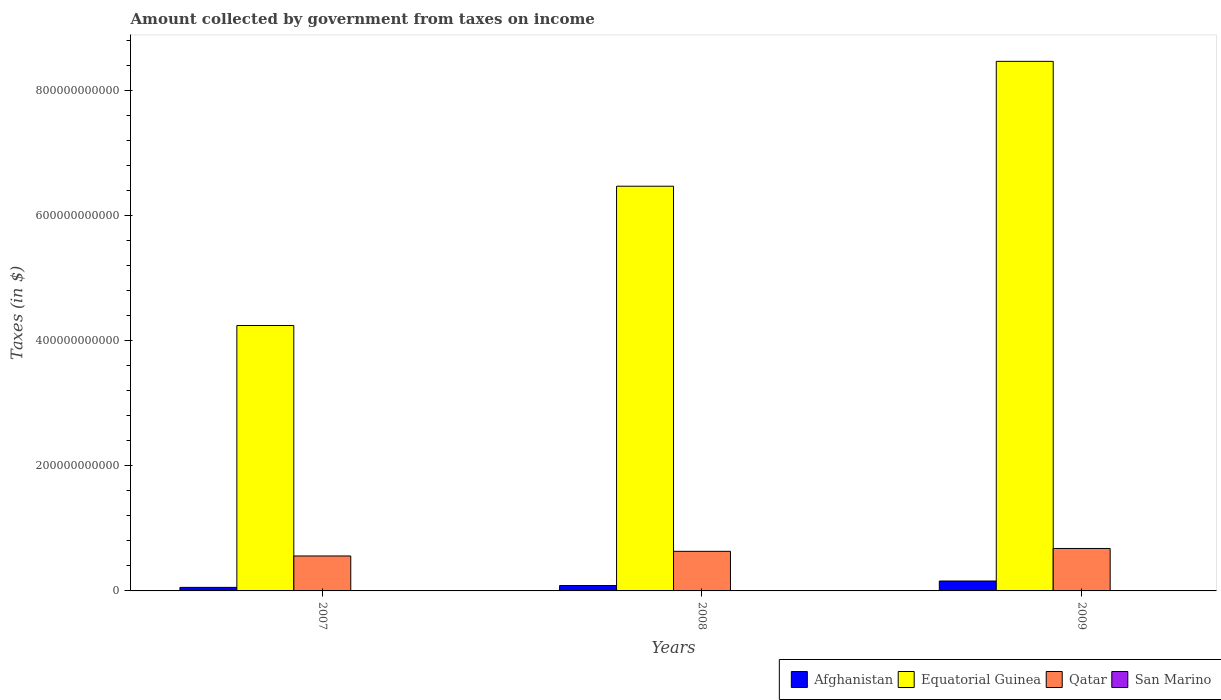How many different coloured bars are there?
Offer a terse response. 4. How many groups of bars are there?
Your answer should be compact. 3. Are the number of bars on each tick of the X-axis equal?
Your answer should be compact. Yes. In how many cases, is the number of bars for a given year not equal to the number of legend labels?
Give a very brief answer. 0. What is the amount collected by government from taxes on income in Equatorial Guinea in 2007?
Provide a succinct answer. 4.24e+11. Across all years, what is the maximum amount collected by government from taxes on income in Qatar?
Your response must be concise. 6.78e+1. Across all years, what is the minimum amount collected by government from taxes on income in San Marino?
Give a very brief answer. 9.80e+07. What is the total amount collected by government from taxes on income in San Marino in the graph?
Offer a terse response. 3.13e+08. What is the difference between the amount collected by government from taxes on income in San Marino in 2007 and that in 2009?
Your answer should be compact. 7.55e+06. What is the difference between the amount collected by government from taxes on income in Afghanistan in 2007 and the amount collected by government from taxes on income in Equatorial Guinea in 2009?
Offer a very short reply. -8.41e+11. What is the average amount collected by government from taxes on income in Equatorial Guinea per year?
Your response must be concise. 6.39e+11. In the year 2008, what is the difference between the amount collected by government from taxes on income in Qatar and amount collected by government from taxes on income in Afghanistan?
Provide a succinct answer. 5.47e+1. What is the ratio of the amount collected by government from taxes on income in Equatorial Guinea in 2007 to that in 2008?
Ensure brevity in your answer.  0.66. What is the difference between the highest and the second highest amount collected by government from taxes on income in Afghanistan?
Make the answer very short. 7.23e+09. What is the difference between the highest and the lowest amount collected by government from taxes on income in Afghanistan?
Your response must be concise. 1.02e+1. In how many years, is the amount collected by government from taxes on income in Equatorial Guinea greater than the average amount collected by government from taxes on income in Equatorial Guinea taken over all years?
Provide a short and direct response. 2. Is it the case that in every year, the sum of the amount collected by government from taxes on income in Qatar and amount collected by government from taxes on income in San Marino is greater than the sum of amount collected by government from taxes on income in Afghanistan and amount collected by government from taxes on income in Equatorial Guinea?
Your answer should be compact. Yes. What does the 3rd bar from the left in 2009 represents?
Keep it short and to the point. Qatar. What does the 4th bar from the right in 2007 represents?
Your answer should be very brief. Afghanistan. Are all the bars in the graph horizontal?
Make the answer very short. No. What is the difference between two consecutive major ticks on the Y-axis?
Ensure brevity in your answer.  2.00e+11. Does the graph contain any zero values?
Your answer should be compact. No. Does the graph contain grids?
Provide a short and direct response. No. Where does the legend appear in the graph?
Provide a short and direct response. Bottom right. How many legend labels are there?
Give a very brief answer. 4. How are the legend labels stacked?
Provide a short and direct response. Horizontal. What is the title of the graph?
Your answer should be very brief. Amount collected by government from taxes on income. Does "Moldova" appear as one of the legend labels in the graph?
Make the answer very short. No. What is the label or title of the X-axis?
Ensure brevity in your answer.  Years. What is the label or title of the Y-axis?
Ensure brevity in your answer.  Taxes (in $). What is the Taxes (in $) of Afghanistan in 2007?
Make the answer very short. 5.64e+09. What is the Taxes (in $) of Equatorial Guinea in 2007?
Provide a short and direct response. 4.24e+11. What is the Taxes (in $) of Qatar in 2007?
Make the answer very short. 5.58e+1. What is the Taxes (in $) of San Marino in 2007?
Make the answer very short. 1.06e+08. What is the Taxes (in $) in Afghanistan in 2008?
Offer a terse response. 8.62e+09. What is the Taxes (in $) of Equatorial Guinea in 2008?
Provide a succinct answer. 6.47e+11. What is the Taxes (in $) of Qatar in 2008?
Give a very brief answer. 6.33e+1. What is the Taxes (in $) in San Marino in 2008?
Ensure brevity in your answer.  1.09e+08. What is the Taxes (in $) of Afghanistan in 2009?
Give a very brief answer. 1.58e+1. What is the Taxes (in $) in Equatorial Guinea in 2009?
Your response must be concise. 8.46e+11. What is the Taxes (in $) in Qatar in 2009?
Offer a very short reply. 6.78e+1. What is the Taxes (in $) in San Marino in 2009?
Ensure brevity in your answer.  9.80e+07. Across all years, what is the maximum Taxes (in $) of Afghanistan?
Provide a short and direct response. 1.58e+1. Across all years, what is the maximum Taxes (in $) in Equatorial Guinea?
Give a very brief answer. 8.46e+11. Across all years, what is the maximum Taxes (in $) of Qatar?
Provide a short and direct response. 6.78e+1. Across all years, what is the maximum Taxes (in $) of San Marino?
Your answer should be compact. 1.09e+08. Across all years, what is the minimum Taxes (in $) of Afghanistan?
Provide a succinct answer. 5.64e+09. Across all years, what is the minimum Taxes (in $) in Equatorial Guinea?
Provide a short and direct response. 4.24e+11. Across all years, what is the minimum Taxes (in $) in Qatar?
Provide a short and direct response. 5.58e+1. Across all years, what is the minimum Taxes (in $) in San Marino?
Keep it short and to the point. 9.80e+07. What is the total Taxes (in $) of Afghanistan in the graph?
Ensure brevity in your answer.  3.01e+1. What is the total Taxes (in $) in Equatorial Guinea in the graph?
Ensure brevity in your answer.  1.92e+12. What is the total Taxes (in $) of Qatar in the graph?
Ensure brevity in your answer.  1.87e+11. What is the total Taxes (in $) in San Marino in the graph?
Offer a very short reply. 3.13e+08. What is the difference between the Taxes (in $) in Afghanistan in 2007 and that in 2008?
Provide a short and direct response. -2.97e+09. What is the difference between the Taxes (in $) in Equatorial Guinea in 2007 and that in 2008?
Offer a terse response. -2.23e+11. What is the difference between the Taxes (in $) in Qatar in 2007 and that in 2008?
Provide a short and direct response. -7.43e+09. What is the difference between the Taxes (in $) of San Marino in 2007 and that in 2008?
Keep it short and to the point. -3.65e+06. What is the difference between the Taxes (in $) in Afghanistan in 2007 and that in 2009?
Your answer should be very brief. -1.02e+1. What is the difference between the Taxes (in $) in Equatorial Guinea in 2007 and that in 2009?
Keep it short and to the point. -4.22e+11. What is the difference between the Taxes (in $) in Qatar in 2007 and that in 2009?
Keep it short and to the point. -1.20e+1. What is the difference between the Taxes (in $) in San Marino in 2007 and that in 2009?
Keep it short and to the point. 7.55e+06. What is the difference between the Taxes (in $) in Afghanistan in 2008 and that in 2009?
Provide a short and direct response. -7.23e+09. What is the difference between the Taxes (in $) of Equatorial Guinea in 2008 and that in 2009?
Provide a succinct answer. -1.99e+11. What is the difference between the Taxes (in $) in Qatar in 2008 and that in 2009?
Offer a very short reply. -4.54e+09. What is the difference between the Taxes (in $) in San Marino in 2008 and that in 2009?
Your answer should be compact. 1.12e+07. What is the difference between the Taxes (in $) of Afghanistan in 2007 and the Taxes (in $) of Equatorial Guinea in 2008?
Ensure brevity in your answer.  -6.41e+11. What is the difference between the Taxes (in $) in Afghanistan in 2007 and the Taxes (in $) in Qatar in 2008?
Provide a succinct answer. -5.76e+1. What is the difference between the Taxes (in $) in Afghanistan in 2007 and the Taxes (in $) in San Marino in 2008?
Provide a short and direct response. 5.54e+09. What is the difference between the Taxes (in $) of Equatorial Guinea in 2007 and the Taxes (in $) of Qatar in 2008?
Your answer should be compact. 3.61e+11. What is the difference between the Taxes (in $) in Equatorial Guinea in 2007 and the Taxes (in $) in San Marino in 2008?
Give a very brief answer. 4.24e+11. What is the difference between the Taxes (in $) in Qatar in 2007 and the Taxes (in $) in San Marino in 2008?
Keep it short and to the point. 5.57e+1. What is the difference between the Taxes (in $) in Afghanistan in 2007 and the Taxes (in $) in Equatorial Guinea in 2009?
Make the answer very short. -8.41e+11. What is the difference between the Taxes (in $) in Afghanistan in 2007 and the Taxes (in $) in Qatar in 2009?
Your answer should be very brief. -6.22e+1. What is the difference between the Taxes (in $) of Afghanistan in 2007 and the Taxes (in $) of San Marino in 2009?
Your answer should be compact. 5.55e+09. What is the difference between the Taxes (in $) of Equatorial Guinea in 2007 and the Taxes (in $) of Qatar in 2009?
Offer a very short reply. 3.56e+11. What is the difference between the Taxes (in $) in Equatorial Guinea in 2007 and the Taxes (in $) in San Marino in 2009?
Provide a succinct answer. 4.24e+11. What is the difference between the Taxes (in $) of Qatar in 2007 and the Taxes (in $) of San Marino in 2009?
Your answer should be compact. 5.57e+1. What is the difference between the Taxes (in $) of Afghanistan in 2008 and the Taxes (in $) of Equatorial Guinea in 2009?
Keep it short and to the point. -8.38e+11. What is the difference between the Taxes (in $) in Afghanistan in 2008 and the Taxes (in $) in Qatar in 2009?
Provide a short and direct response. -5.92e+1. What is the difference between the Taxes (in $) of Afghanistan in 2008 and the Taxes (in $) of San Marino in 2009?
Offer a very short reply. 8.52e+09. What is the difference between the Taxes (in $) of Equatorial Guinea in 2008 and the Taxes (in $) of Qatar in 2009?
Offer a very short reply. 5.79e+11. What is the difference between the Taxes (in $) in Equatorial Guinea in 2008 and the Taxes (in $) in San Marino in 2009?
Give a very brief answer. 6.47e+11. What is the difference between the Taxes (in $) of Qatar in 2008 and the Taxes (in $) of San Marino in 2009?
Ensure brevity in your answer.  6.32e+1. What is the average Taxes (in $) of Afghanistan per year?
Give a very brief answer. 1.00e+1. What is the average Taxes (in $) of Equatorial Guinea per year?
Provide a short and direct response. 6.39e+11. What is the average Taxes (in $) of Qatar per year?
Provide a succinct answer. 6.23e+1. What is the average Taxes (in $) in San Marino per year?
Offer a terse response. 1.04e+08. In the year 2007, what is the difference between the Taxes (in $) of Afghanistan and Taxes (in $) of Equatorial Guinea?
Make the answer very short. -4.18e+11. In the year 2007, what is the difference between the Taxes (in $) of Afghanistan and Taxes (in $) of Qatar?
Keep it short and to the point. -5.02e+1. In the year 2007, what is the difference between the Taxes (in $) of Afghanistan and Taxes (in $) of San Marino?
Keep it short and to the point. 5.54e+09. In the year 2007, what is the difference between the Taxes (in $) in Equatorial Guinea and Taxes (in $) in Qatar?
Provide a succinct answer. 3.68e+11. In the year 2007, what is the difference between the Taxes (in $) in Equatorial Guinea and Taxes (in $) in San Marino?
Provide a short and direct response. 4.24e+11. In the year 2007, what is the difference between the Taxes (in $) of Qatar and Taxes (in $) of San Marino?
Make the answer very short. 5.57e+1. In the year 2008, what is the difference between the Taxes (in $) of Afghanistan and Taxes (in $) of Equatorial Guinea?
Offer a terse response. -6.38e+11. In the year 2008, what is the difference between the Taxes (in $) in Afghanistan and Taxes (in $) in Qatar?
Your response must be concise. -5.47e+1. In the year 2008, what is the difference between the Taxes (in $) of Afghanistan and Taxes (in $) of San Marino?
Your response must be concise. 8.51e+09. In the year 2008, what is the difference between the Taxes (in $) of Equatorial Guinea and Taxes (in $) of Qatar?
Provide a short and direct response. 5.83e+11. In the year 2008, what is the difference between the Taxes (in $) of Equatorial Guinea and Taxes (in $) of San Marino?
Provide a succinct answer. 6.47e+11. In the year 2008, what is the difference between the Taxes (in $) of Qatar and Taxes (in $) of San Marino?
Make the answer very short. 6.32e+1. In the year 2009, what is the difference between the Taxes (in $) of Afghanistan and Taxes (in $) of Equatorial Guinea?
Offer a very short reply. -8.30e+11. In the year 2009, what is the difference between the Taxes (in $) in Afghanistan and Taxes (in $) in Qatar?
Your response must be concise. -5.20e+1. In the year 2009, what is the difference between the Taxes (in $) in Afghanistan and Taxes (in $) in San Marino?
Offer a terse response. 1.57e+1. In the year 2009, what is the difference between the Taxes (in $) in Equatorial Guinea and Taxes (in $) in Qatar?
Provide a short and direct response. 7.78e+11. In the year 2009, what is the difference between the Taxes (in $) in Equatorial Guinea and Taxes (in $) in San Marino?
Provide a succinct answer. 8.46e+11. In the year 2009, what is the difference between the Taxes (in $) of Qatar and Taxes (in $) of San Marino?
Give a very brief answer. 6.77e+1. What is the ratio of the Taxes (in $) in Afghanistan in 2007 to that in 2008?
Give a very brief answer. 0.66. What is the ratio of the Taxes (in $) in Equatorial Guinea in 2007 to that in 2008?
Offer a terse response. 0.66. What is the ratio of the Taxes (in $) of Qatar in 2007 to that in 2008?
Ensure brevity in your answer.  0.88. What is the ratio of the Taxes (in $) of San Marino in 2007 to that in 2008?
Offer a very short reply. 0.97. What is the ratio of the Taxes (in $) of Afghanistan in 2007 to that in 2009?
Your answer should be very brief. 0.36. What is the ratio of the Taxes (in $) of Equatorial Guinea in 2007 to that in 2009?
Make the answer very short. 0.5. What is the ratio of the Taxes (in $) of Qatar in 2007 to that in 2009?
Your response must be concise. 0.82. What is the ratio of the Taxes (in $) of San Marino in 2007 to that in 2009?
Ensure brevity in your answer.  1.08. What is the ratio of the Taxes (in $) in Afghanistan in 2008 to that in 2009?
Ensure brevity in your answer.  0.54. What is the ratio of the Taxes (in $) in Equatorial Guinea in 2008 to that in 2009?
Provide a short and direct response. 0.76. What is the ratio of the Taxes (in $) of Qatar in 2008 to that in 2009?
Provide a short and direct response. 0.93. What is the ratio of the Taxes (in $) of San Marino in 2008 to that in 2009?
Provide a succinct answer. 1.11. What is the difference between the highest and the second highest Taxes (in $) of Afghanistan?
Your answer should be compact. 7.23e+09. What is the difference between the highest and the second highest Taxes (in $) in Equatorial Guinea?
Provide a succinct answer. 1.99e+11. What is the difference between the highest and the second highest Taxes (in $) of Qatar?
Your answer should be very brief. 4.54e+09. What is the difference between the highest and the second highest Taxes (in $) of San Marino?
Ensure brevity in your answer.  3.65e+06. What is the difference between the highest and the lowest Taxes (in $) in Afghanistan?
Your response must be concise. 1.02e+1. What is the difference between the highest and the lowest Taxes (in $) of Equatorial Guinea?
Provide a short and direct response. 4.22e+11. What is the difference between the highest and the lowest Taxes (in $) of Qatar?
Your answer should be compact. 1.20e+1. What is the difference between the highest and the lowest Taxes (in $) in San Marino?
Your response must be concise. 1.12e+07. 